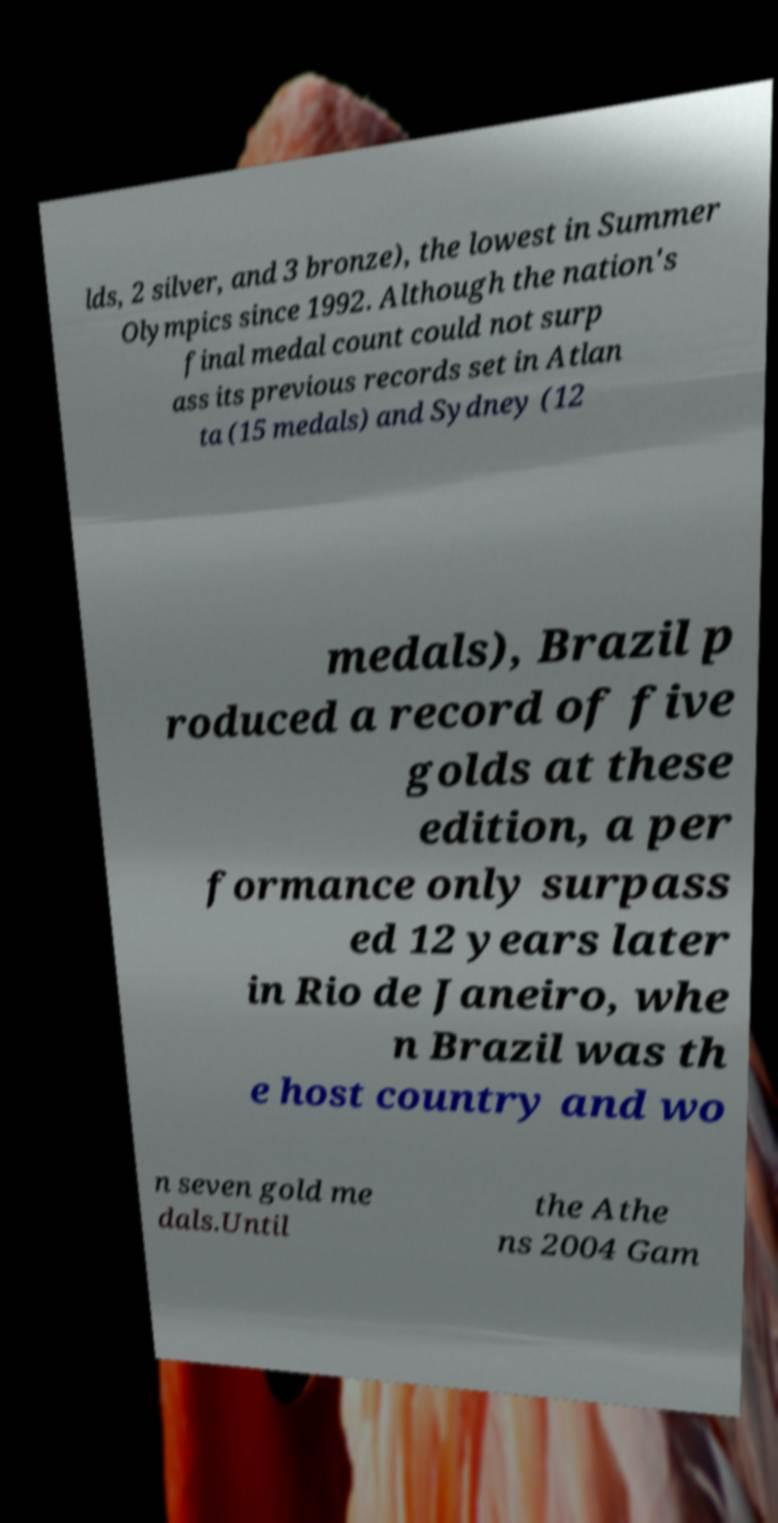What messages or text are displayed in this image? I need them in a readable, typed format. lds, 2 silver, and 3 bronze), the lowest in Summer Olympics since 1992. Although the nation's final medal count could not surp ass its previous records set in Atlan ta (15 medals) and Sydney (12 medals), Brazil p roduced a record of five golds at these edition, a per formance only surpass ed 12 years later in Rio de Janeiro, whe n Brazil was th e host country and wo n seven gold me dals.Until the Athe ns 2004 Gam 